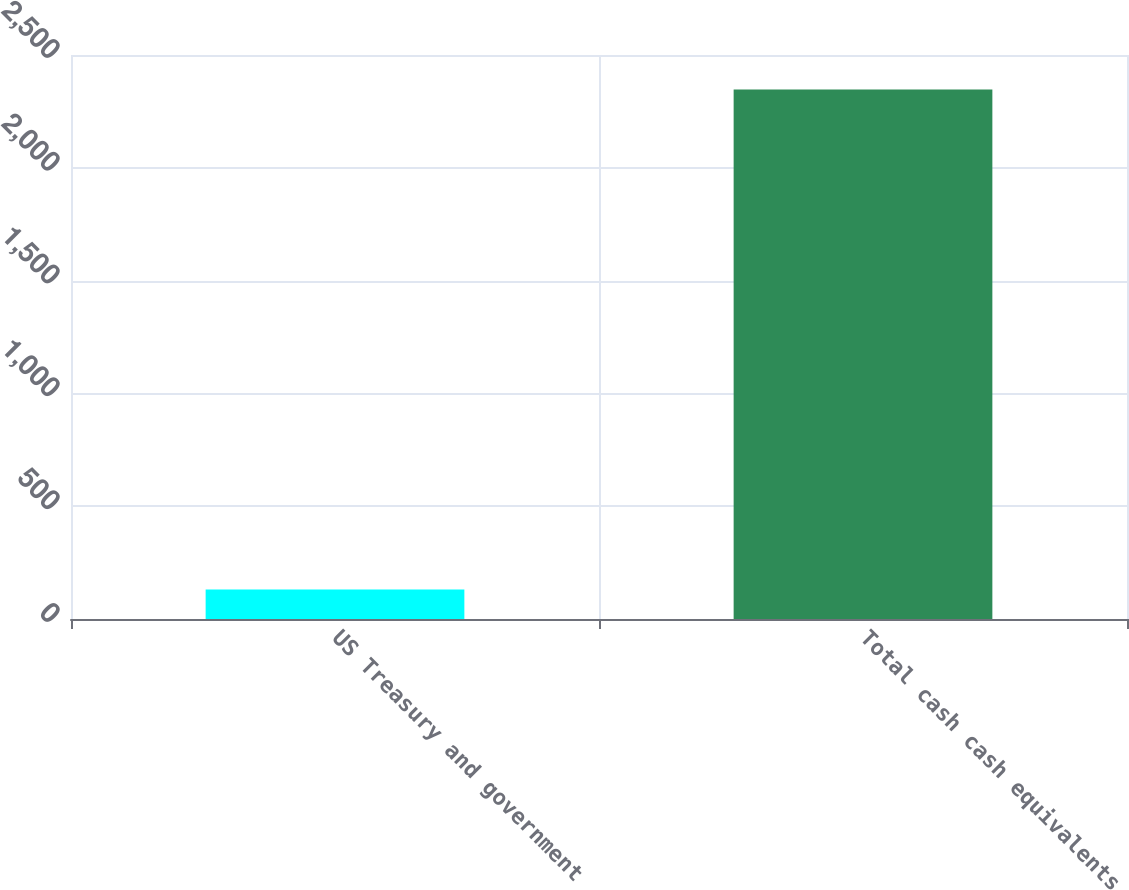Convert chart to OTSL. <chart><loc_0><loc_0><loc_500><loc_500><bar_chart><fcel>US Treasury and government<fcel>Total cash cash equivalents<nl><fcel>131<fcel>2347<nl></chart> 